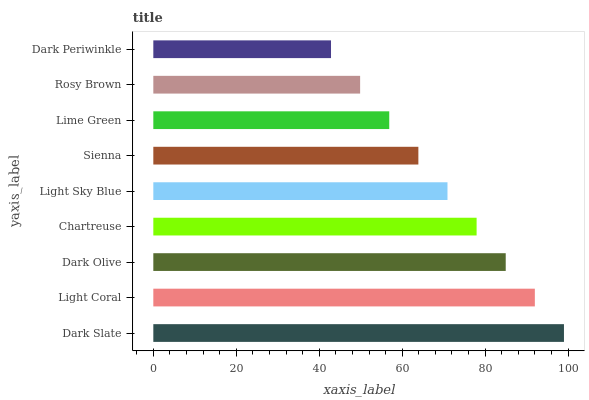Is Dark Periwinkle the minimum?
Answer yes or no. Yes. Is Dark Slate the maximum?
Answer yes or no. Yes. Is Light Coral the minimum?
Answer yes or no. No. Is Light Coral the maximum?
Answer yes or no. No. Is Dark Slate greater than Light Coral?
Answer yes or no. Yes. Is Light Coral less than Dark Slate?
Answer yes or no. Yes. Is Light Coral greater than Dark Slate?
Answer yes or no. No. Is Dark Slate less than Light Coral?
Answer yes or no. No. Is Light Sky Blue the high median?
Answer yes or no. Yes. Is Light Sky Blue the low median?
Answer yes or no. Yes. Is Light Coral the high median?
Answer yes or no. No. Is Lime Green the low median?
Answer yes or no. No. 